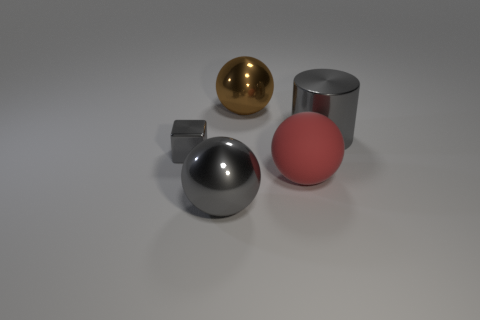What is the material of the small thing that is the same color as the large metallic cylinder?
Offer a terse response. Metal. Is there any other thing that is the same size as the gray block?
Offer a terse response. No. Do the block and the large metal cylinder have the same color?
Provide a short and direct response. Yes. How many large metal cylinders have the same color as the tiny object?
Give a very brief answer. 1. What number of gray cylinders have the same material as the tiny block?
Provide a short and direct response. 1. What material is the large brown thing?
Provide a succinct answer. Metal. There is a big red thing that is behind the big metal thing that is in front of the gray shiny thing to the right of the large gray ball; what is its material?
Provide a short and direct response. Rubber. Is there anything else that is the same shape as the tiny gray object?
Keep it short and to the point. No. There is another big rubber object that is the same shape as the big brown object; what is its color?
Offer a terse response. Red. Is the color of the large shiny sphere that is in front of the shiny cylinder the same as the big metallic object on the right side of the rubber thing?
Keep it short and to the point. Yes. 